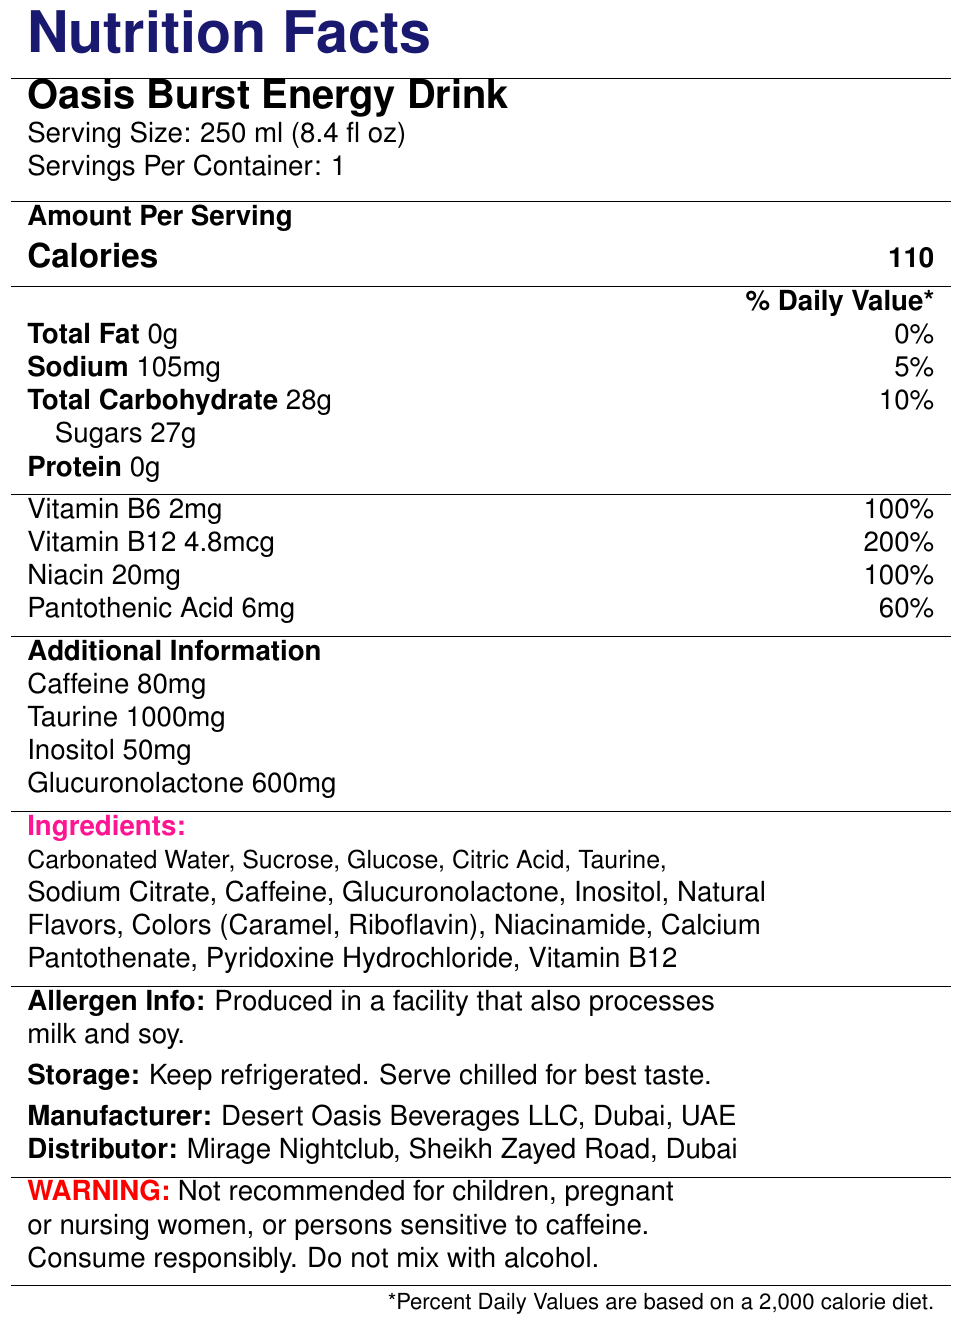what is the serving size of Oasis Burst Energy Drink? The serving size is explicitly mentioned in the document under the 'Serving Size' section.
Answer: 250 ml (8.4 fl oz) how many calories are there per serving? The number of calories per serving is listed under the 'Calories' section.
Answer: 110 what is the amount of vitamin B12 per serving? The document provides the amount under the 'Vitamin B12' section.
Answer: 4.8 mcg what are the storage instructions for the drink? The storage instructions are clearly stated under the 'Storage' section.
Answer: Keep refrigerated. Serve chilled for best taste. how much caffeine is in one serving of Oasis Burst Energy Drink? The amount of caffeine is noted under the 'Additional Information' section.
Answer: 80 mg what percentage of the daily value of niacin does the drink provide? The drink provides 100% of the daily value for niacin as listed in the document under the 'Niacin' section.
Answer: 100% what allergens might be present? A. Nuts B. Gluten C. Milk and Soy D. Fish The allergen information mentions milk and soy as possible allergens.
Answer: C which of these ingredients is not listed in the document? I. Taurine II. Inositol III. Aspartame Taurine and Inositol are mentioned in the document; Aspartame is not.
Answer: III. Aspartame is the energy drink recommended for pregnant women? The warning section advises not to consume the drink if you are pregnant.
Answer: No describe the main idea of the document. The document aims to inform consumers about the nutritional content and important information related to the energy drink.
Answer: The document provides detailed nutritional facts for Oasis Burst Energy Drink, including serving size, calories, fat, carbohydrates, protein, vitamins, caffeine content, ingredients, allergen information, storage instructions, and warnings. how much taurine is there in one serving? The amount of taurine per serving is stated clearly under the 'Additional Information' section.
Answer: 1000 mg what is the total amount of sugars in one serving? The total amount of sugars is listed under the 'Sugars' part of the 'Total Carbohydrate' section.
Answer: 27 g is the product distributed by Mirage Nightclub? The document mentions that the distributor is Mirage Nightclub, Sheikh Zayed Road, Dubai.
Answer: Yes can you consume this drink with alcohol? The warning section clearly states not to mix with alcohol.
Answer: No which vitamin provides the highest percentage of daily value? A. Vitamin B6 B. Vitamin B12 C. Niacin D. Pantothenic Acid Vitamin B12 provides 200% of the daily value, which is the highest percentage among the listed vitamins.
Answer: B where is the manufacturer located? The manufacturer is Desert Oasis Beverages LLC, Dubai, UAE, as stated in the document.
Answer: Dubai, UAE how many servings are there per container of the energy drink? The number of servings per container is specified in the 'Servings Per Container' section.
Answer: 1 what is the sodium content of one serving? The sodium content is listed under the 'Sodium' section.
Answer: 105 mg how is the document formatted? The format is meant to organize information clearly and make it easily accessible.
Answer: The document is formatted in a tabular form with different sections providing nutritional facts, additional information, ingredients, allergen info, storage instructions, manufacturer and distributor details, and warnings. what is the weight of glucuronolactone in one serving? The weight of glucuronolactone per serving is mentioned under the 'Additional Information' section.
Answer: 600 mg does the drink contain any protein? The protein content is listed as 0g in the document.
Answer: No 